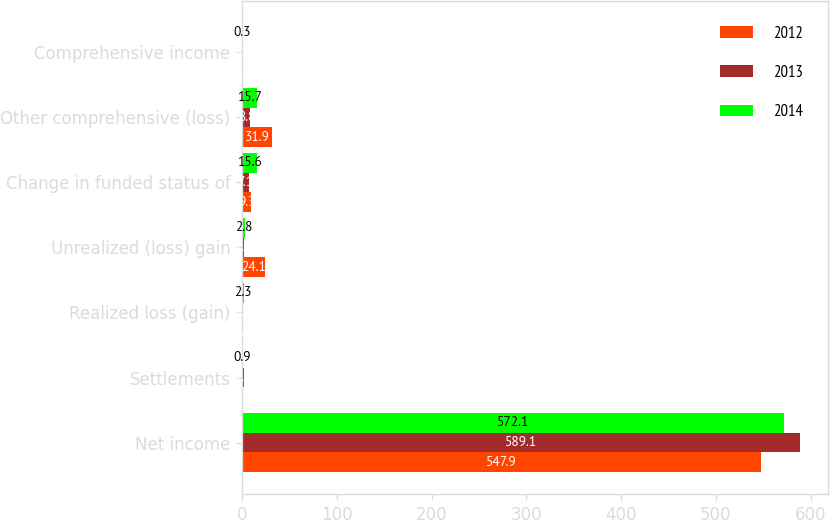Convert chart. <chart><loc_0><loc_0><loc_500><loc_500><stacked_bar_chart><ecel><fcel>Net income<fcel>Settlements<fcel>Realized loss (gain)<fcel>Unrealized (loss) gain<fcel>Change in funded status of<fcel>Other comprehensive (loss)<fcel>Comprehensive income<nl><fcel>2012<fcel>547.9<fcel>0.3<fcel>1.2<fcel>24.1<fcel>9.3<fcel>31.9<fcel>0.3<nl><fcel>2013<fcel>589.1<fcel>1.7<fcel>0.2<fcel>2.3<fcel>7.1<fcel>8.8<fcel>0.2<nl><fcel>2014<fcel>572.1<fcel>0.9<fcel>2.3<fcel>2.8<fcel>15.6<fcel>15.7<fcel>0.3<nl></chart> 